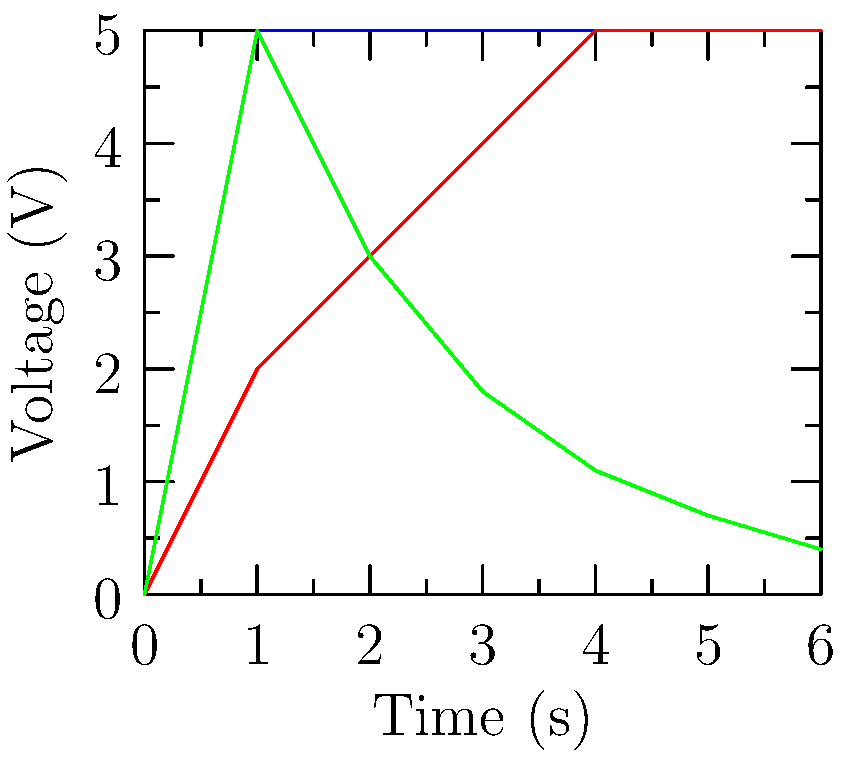As a biochemist familiar with analyzing complex data sets, consider the voltage-time graphs for three electrical components (A, B, and C) shown above. Which component most likely represents a capacitor charging through a resistor, and why? To determine which component represents a capacitor charging through a resistor, we need to analyze the characteristics of each curve:

1. Component A: Shows an instant rise to 5V and remains constant. This is typical of an ideal voltage source or a fully charged capacitor.

2. Component B: Displays a gradual increase in voltage, eventually reaching a steady state. This could represent various scenarios, but not a typical RC charging circuit.

3. Component C: Exhibits an exponential decay curve, starting at a maximum voltage and gradually decreasing over time.

The behavior of a capacitor charging through a resistor is characterized by an exponential rise in voltage, described by the equation:

$$ V(t) = V_0(1 - e^{-t/RC}) $$

Where $V_0$ is the supply voltage, $R$ is the resistance, and $C$ is the capacitance.

Component B most closely resembles this behavior. The voltage starts at 0V and increases exponentially, eventually approaching a steady-state value (in this case, 5V). This curve is consistent with the charging of a capacitor through a resistor.

Components A and C do not match this behavior:
- A shows an instant charge, which is not possible in a real RC circuit.
- C shows a discharge curve, which would represent a capacitor discharging through a resistor, not charging.

Therefore, Component B most likely represents a capacitor charging through a resistor.
Answer: Component B 